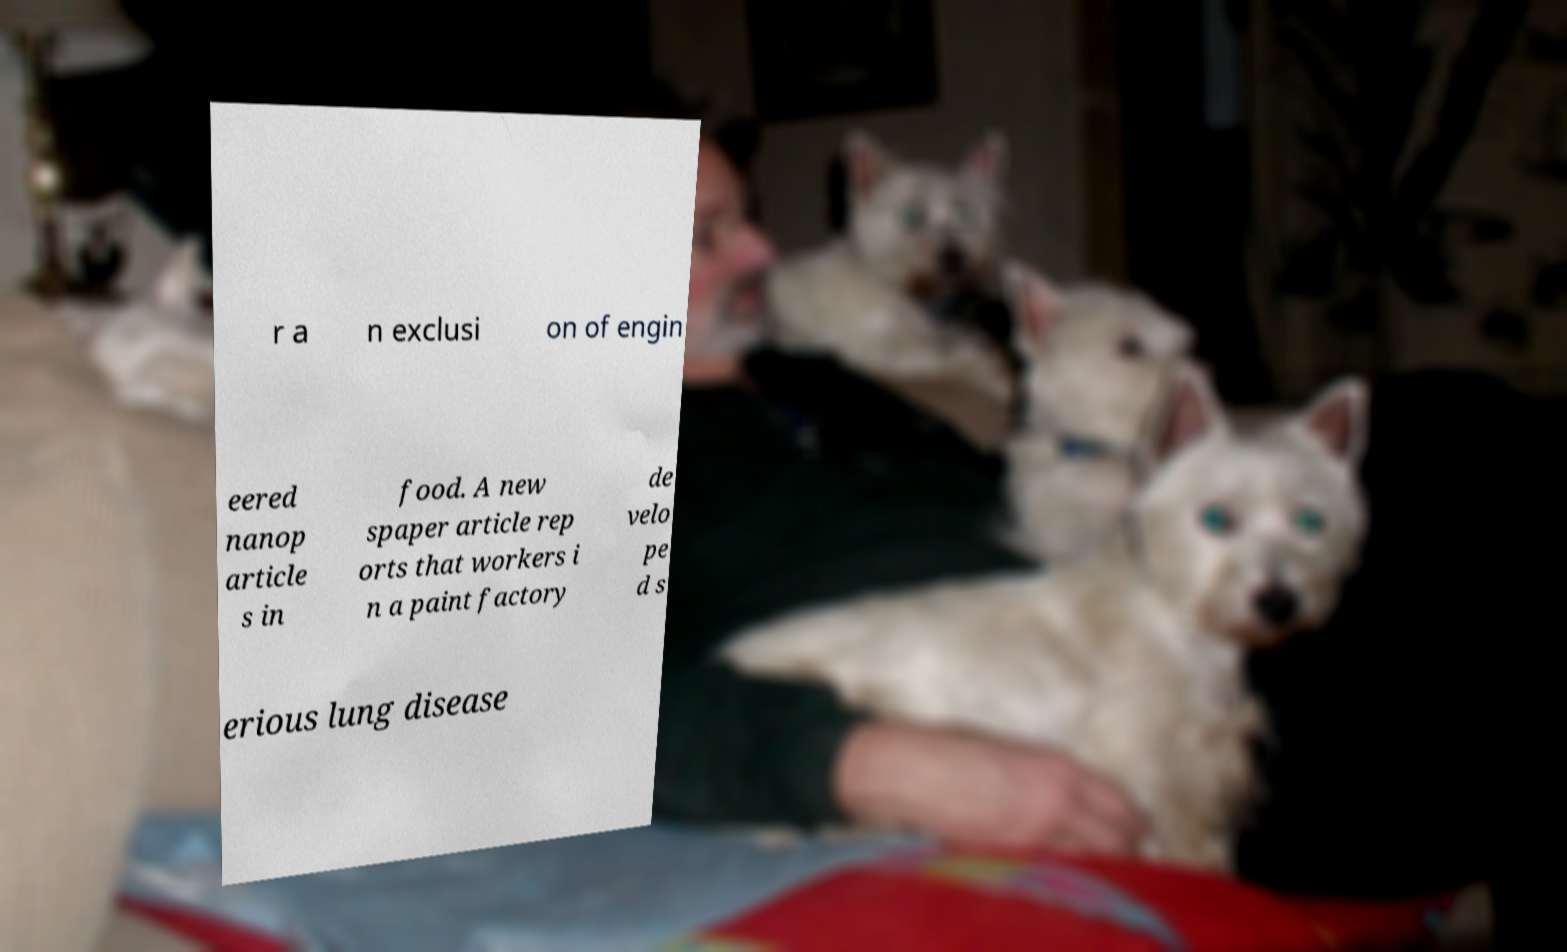Can you read and provide the text displayed in the image?This photo seems to have some interesting text. Can you extract and type it out for me? r a n exclusi on of engin eered nanop article s in food. A new spaper article rep orts that workers i n a paint factory de velo pe d s erious lung disease 